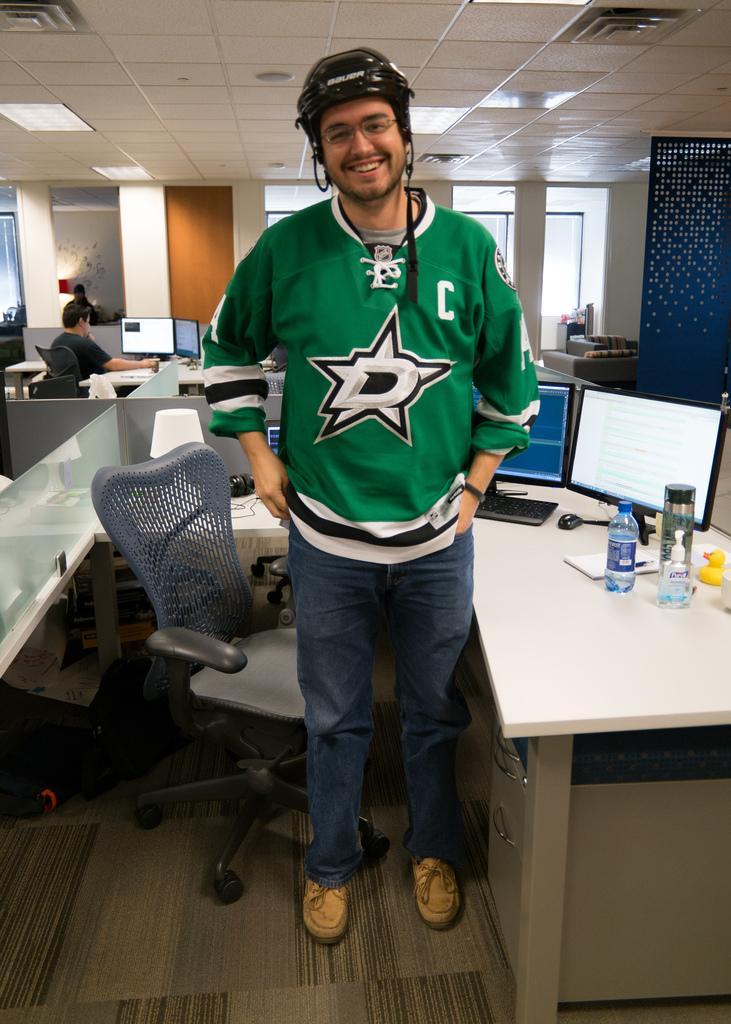Could you give a brief overview of what you see in this image? Here in the front we can see a person standing wearing helmet and smiling and there is a chair and table present with systems, bottles present, behind him also we can see people sitting on chairs 